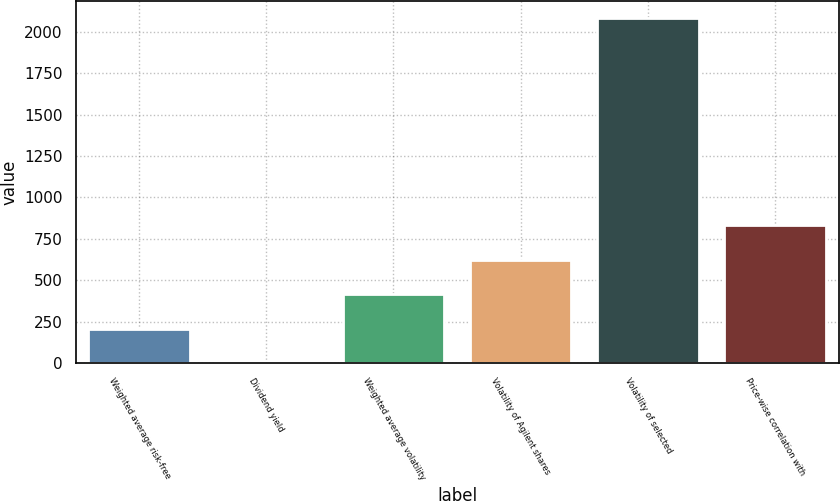<chart> <loc_0><loc_0><loc_500><loc_500><bar_chart><fcel>Weighted average risk-free<fcel>Dividend yield<fcel>Weighted average volatility<fcel>Volatility of Agilent shares<fcel>Volatility of selected<fcel>Price-wise correlation with<nl><fcel>208.32<fcel>0.36<fcel>416.28<fcel>624.24<fcel>2080<fcel>832.2<nl></chart> 